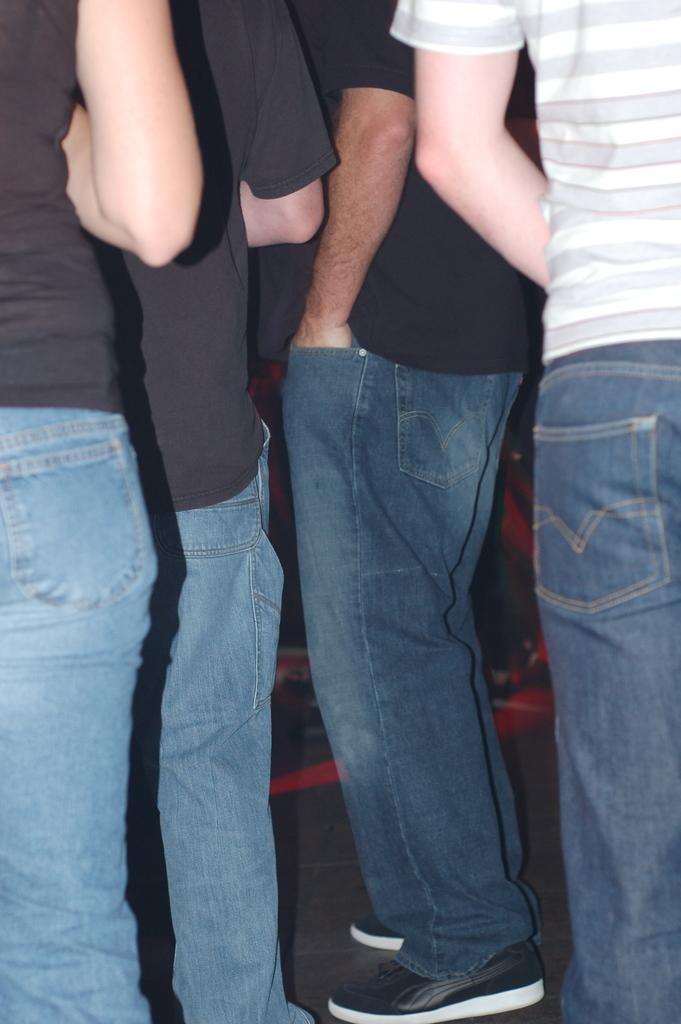How many people are in the image? There are four persons in the image. What colors are the T-shirts of the majority of the persons? Three of the persons are wearing black T-shirts. What color is the T-shirt of the remaining person? One person is wearing a white T-shirt. What position are the persons in the image? All the persons are standing. What health advice is the mom giving to the person in the white T-shirt in the image? There is no mom or health advice present in the image. What part of the body is the person in the white T-shirt touching in the image? There is no indication of any body part being touched by the person in the white T-shirt in the image. 